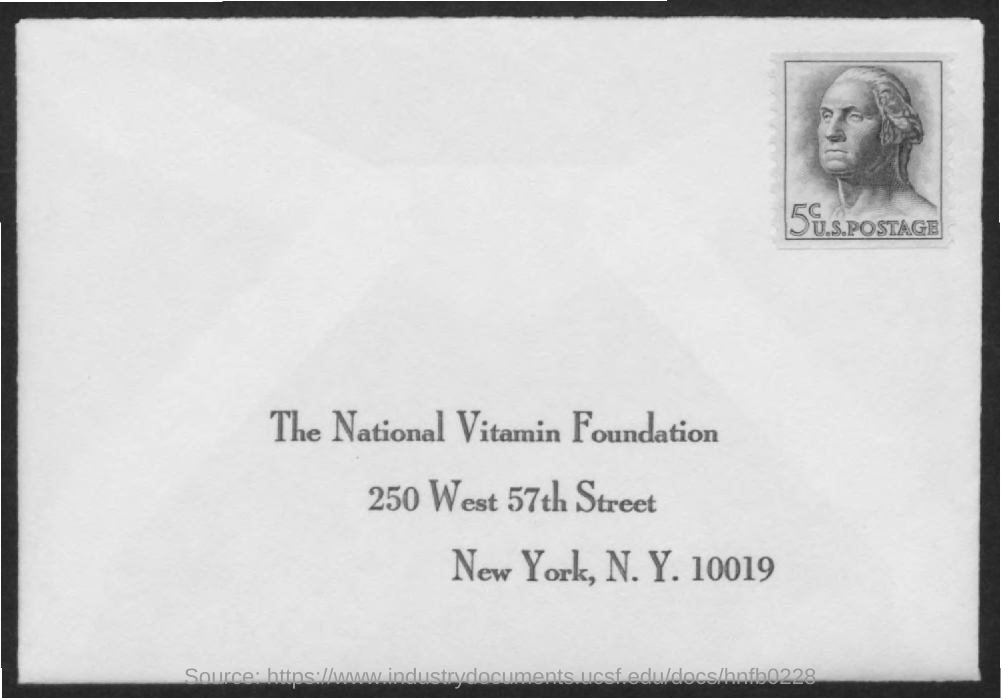Identify some key points in this picture. The title of the document is "What is the title of the document? the national vitamin foundation.. 